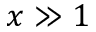Convert formula to latex. <formula><loc_0><loc_0><loc_500><loc_500>x \gg 1</formula> 